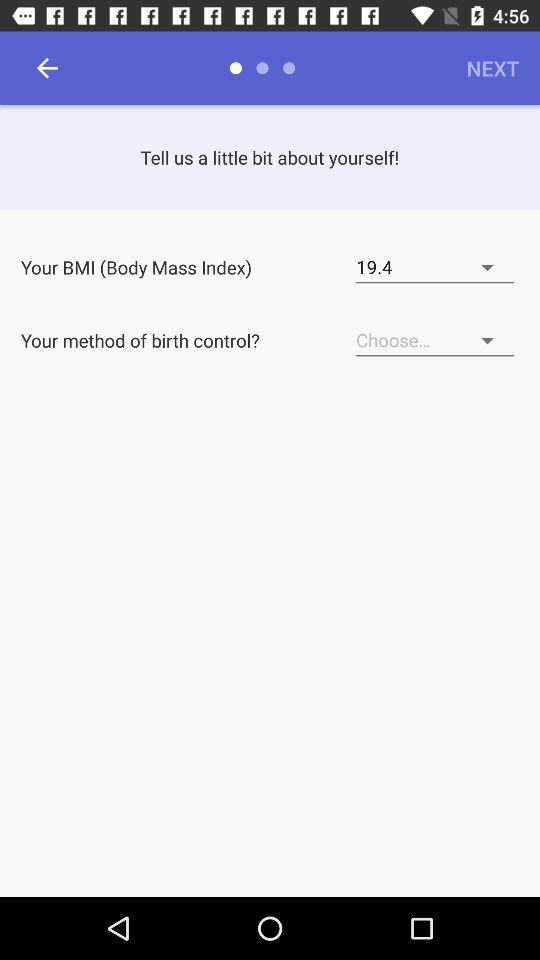How much is the BMI? The BMI is 19.4. 